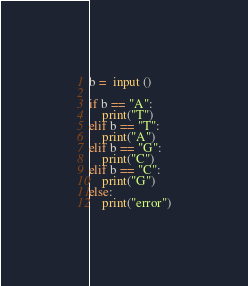<code> <loc_0><loc_0><loc_500><loc_500><_Python_>b =  input ()

if b == "A":
    print("T")
elif b == "T":
    print("A")
elif b == "G":
    print("C")
elif b == "C":
    print("G")
else:
    print("error")</code> 